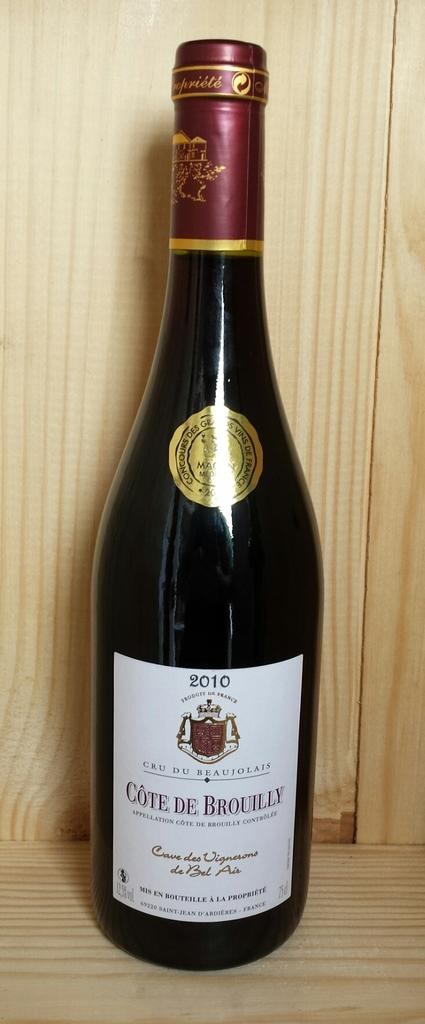<image>
Relay a brief, clear account of the picture shown. A bottle of wine has the year 2010 on the label. 